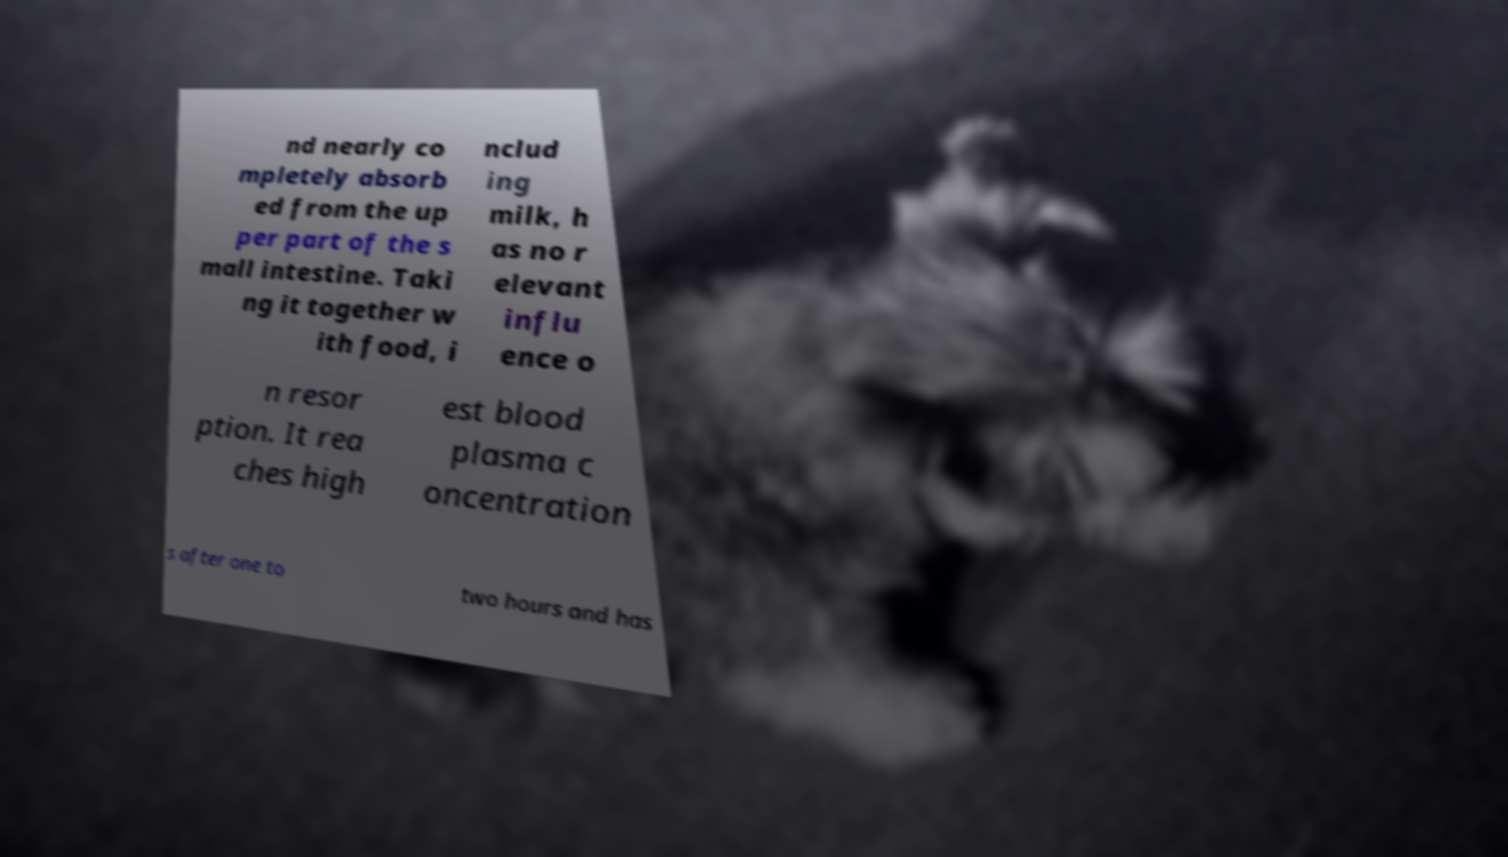Please identify and transcribe the text found in this image. nd nearly co mpletely absorb ed from the up per part of the s mall intestine. Taki ng it together w ith food, i nclud ing milk, h as no r elevant influ ence o n resor ption. It rea ches high est blood plasma c oncentration s after one to two hours and has 